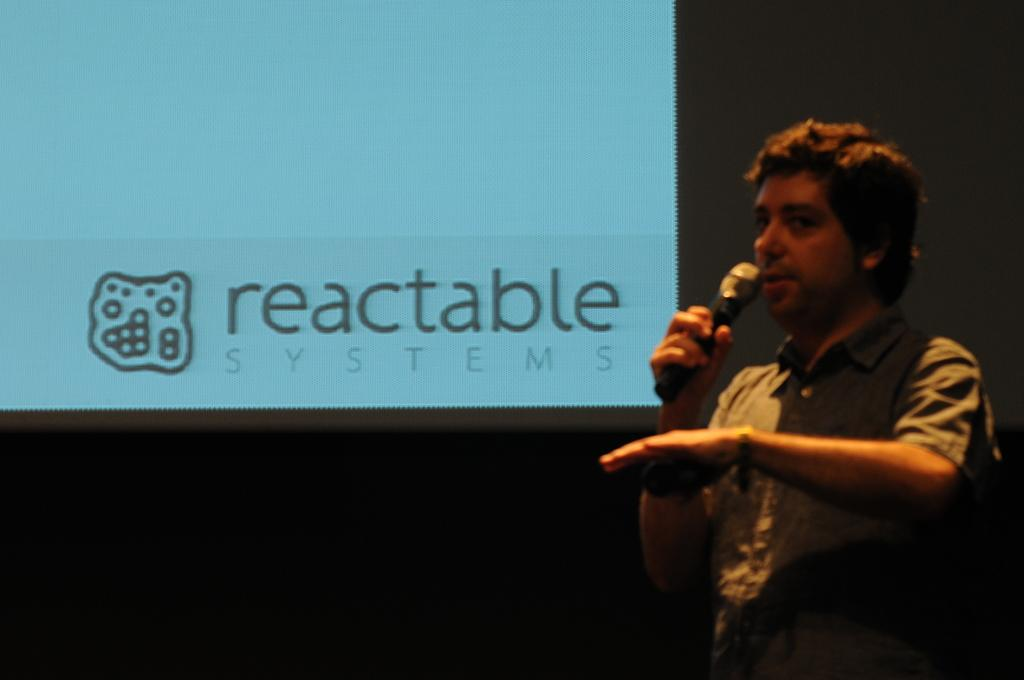Who is the main subject of subject in the image? There is a man in the image. What is the man holding in the image? The man is holding a microphone. What can be seen on the left side of the image? There is a screen on the left side of the image. What type of rifle is the man using to sort items in the image? There is no rifle or sorting activity present in the image. The man is holding a microphone, and there is a screen on the left side of the image. 